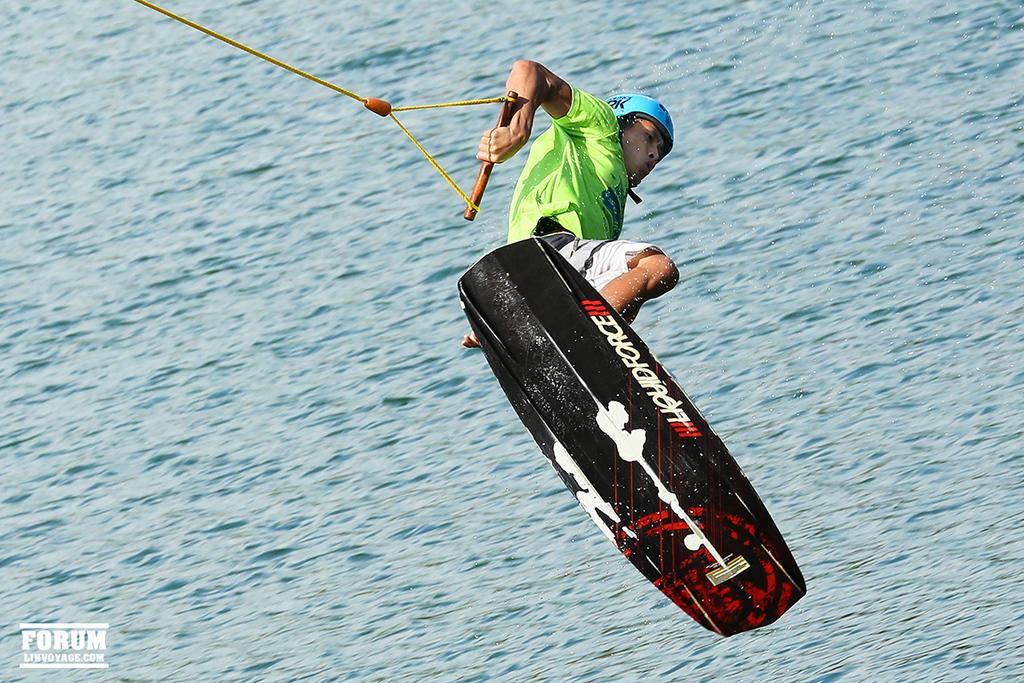Who or what is the main subject in the image? There is a person in the image. What is the person doing in the image? The person is on a surfboard. What is the person holding in the image? The person is holding a rope. What type of environment is depicted in the image? There is water visible at the bottom of the image. Where is the brush used to clean the cobweb in the image? There is no brush or cobweb present in the image. 